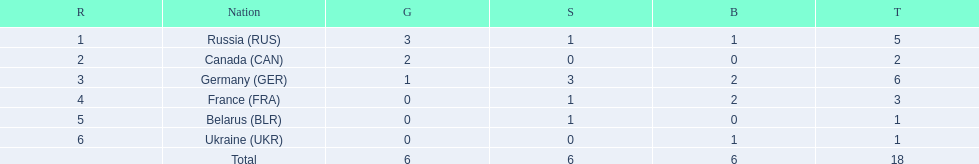What are all the countries in the 1994 winter olympics biathlon? Russia (RUS), Canada (CAN), Germany (GER), France (FRA), Belarus (BLR), Ukraine (UKR). Which of these received at least one gold medal? Russia (RUS), Canada (CAN), Germany (GER). Which of these received no silver or bronze medals? Canada (CAN). 